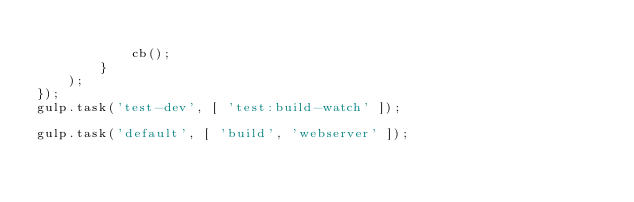Convert code to text. <code><loc_0><loc_0><loc_500><loc_500><_JavaScript_>
            cb();
        }
    );
});
gulp.task('test-dev', [ 'test:build-watch' ]);

gulp.task('default', [ 'build', 'webserver' ]);
</code> 